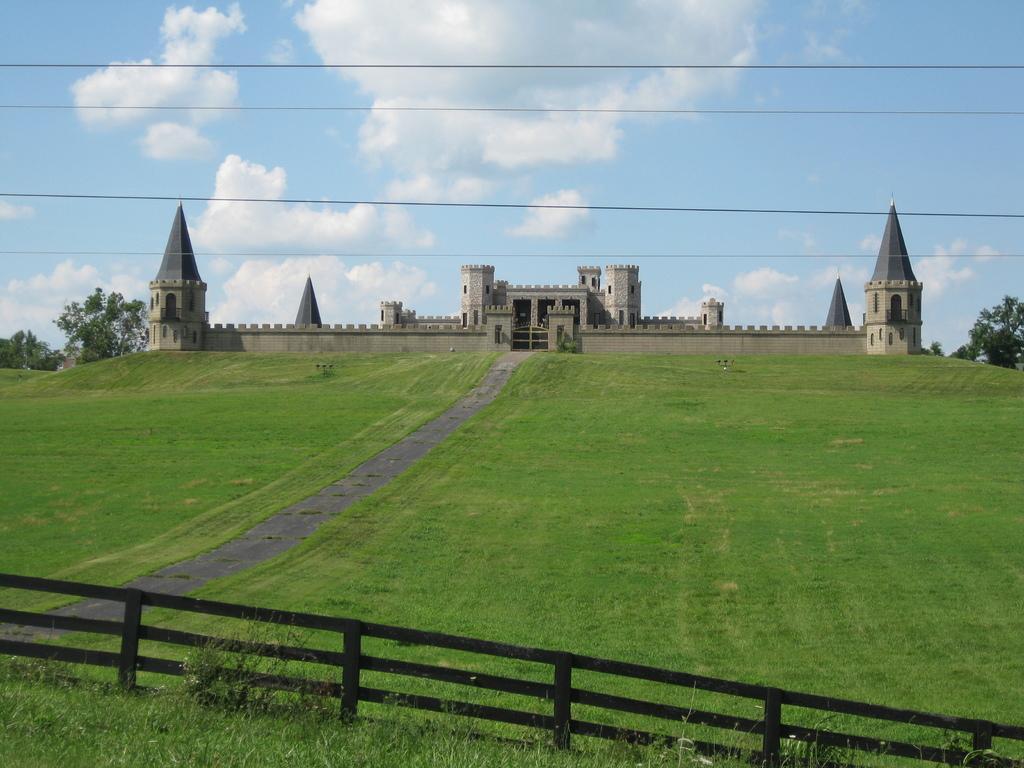Can you describe this image briefly? In this picture I can see there is a fort in the backdrop and there is a walkway, there is grass, plants and a fence. There are trees in the backdrop and the sky is clear. 